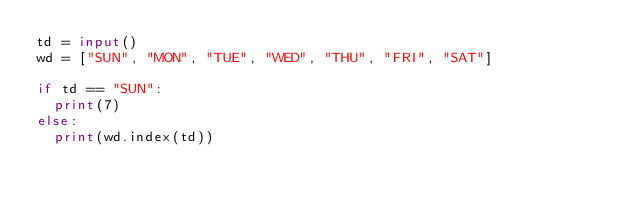<code> <loc_0><loc_0><loc_500><loc_500><_Python_>td = input()
wd = ["SUN", "MON", "TUE", "WED", "THU", "FRI", "SAT"]

if td == "SUN":
  print(7)
else:
  print(wd.index(td))</code> 